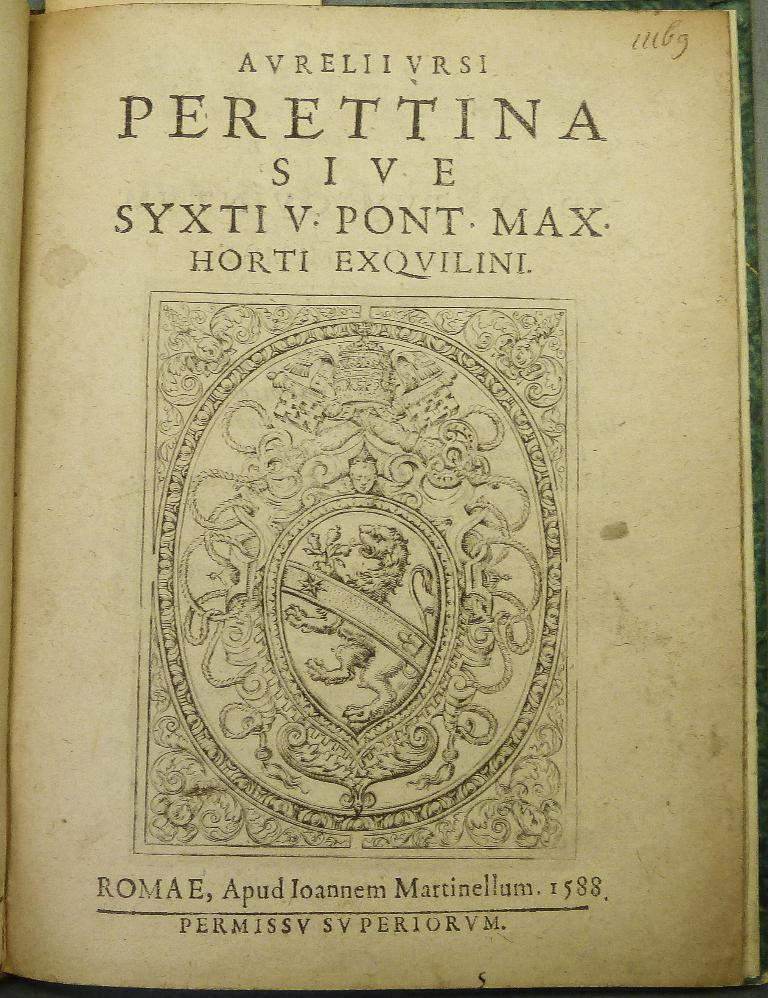Provide a one-sentence caption for the provided image. An old book is open to the title page that says Perettina Sive. 